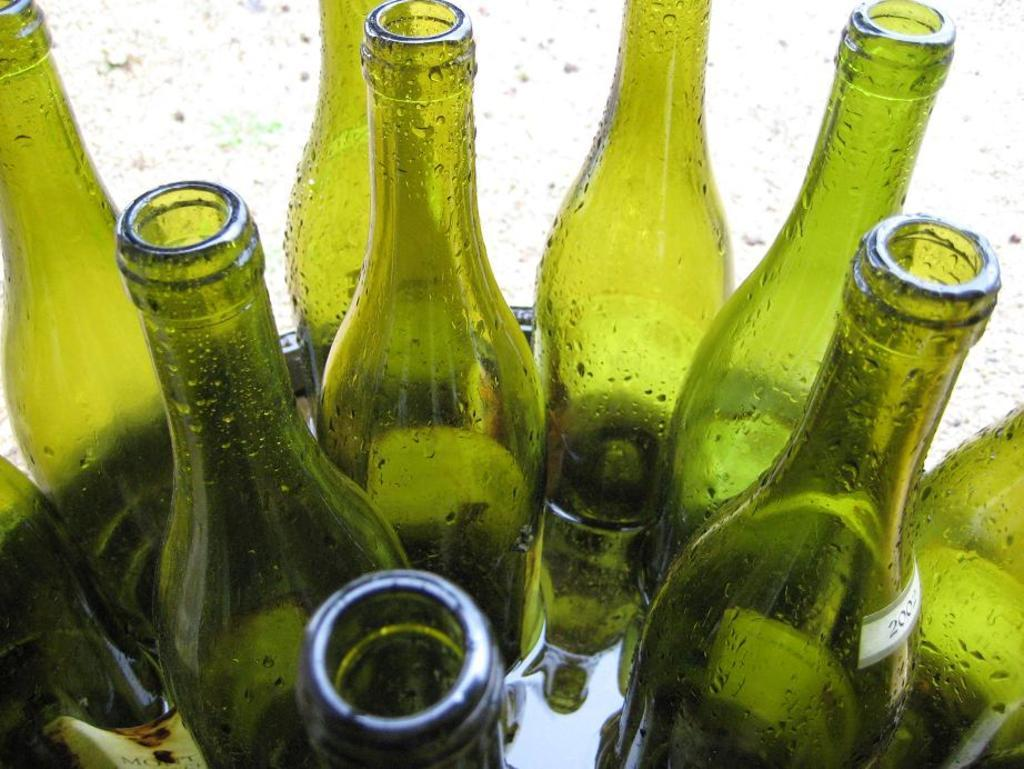What objects are present in the image in large quantities? There are many green bottles in the image. How are the green bottles arranged or stored? The green bottles are kept in a bowl. What is the state of the contents inside the bowl? The bowl is filled with water. What type of design can be seen on the yoke of the horses in the image? There are no horses or yokes present in the image; it features many green bottles in a bowl filled with water. 